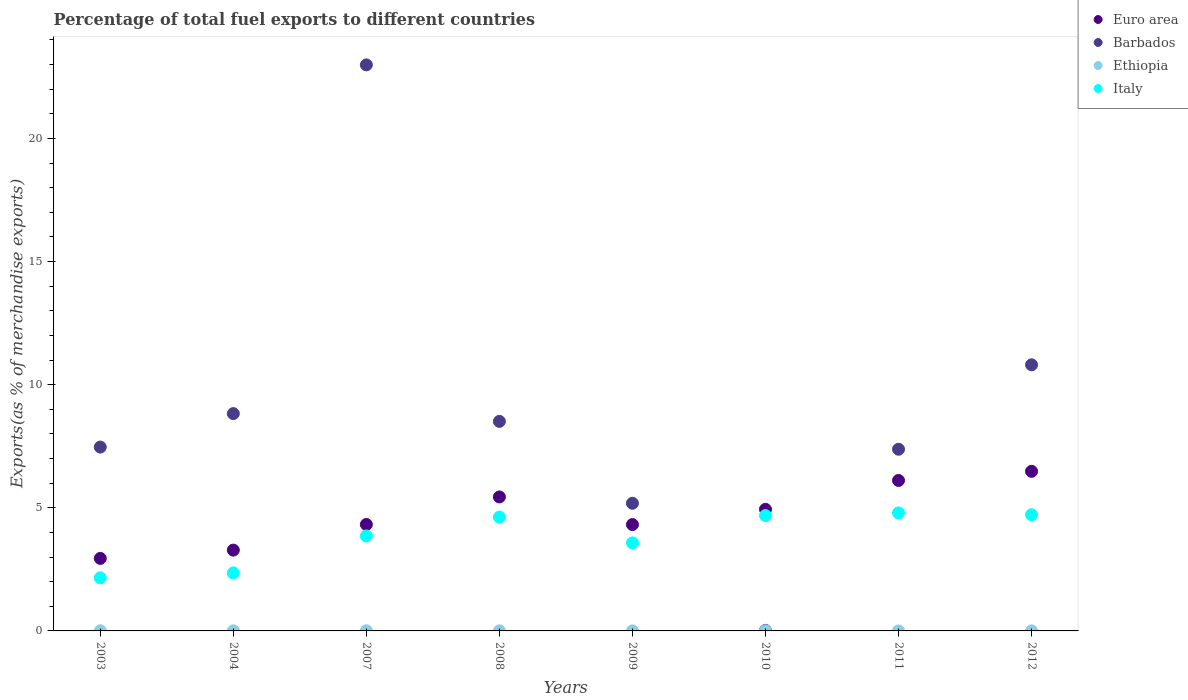What is the percentage of exports to different countries in Italy in 2010?
Your answer should be compact. 4.69. Across all years, what is the maximum percentage of exports to different countries in Ethiopia?
Give a very brief answer. 0.01. Across all years, what is the minimum percentage of exports to different countries in Barbados?
Offer a very short reply. 0.02. What is the total percentage of exports to different countries in Barbados in the graph?
Your answer should be compact. 71.18. What is the difference between the percentage of exports to different countries in Ethiopia in 2004 and that in 2008?
Provide a succinct answer. -0. What is the difference between the percentage of exports to different countries in Barbados in 2004 and the percentage of exports to different countries in Ethiopia in 2003?
Your response must be concise. 8.82. What is the average percentage of exports to different countries in Euro area per year?
Your response must be concise. 4.73. In the year 2007, what is the difference between the percentage of exports to different countries in Ethiopia and percentage of exports to different countries in Euro area?
Ensure brevity in your answer.  -4.32. What is the ratio of the percentage of exports to different countries in Euro area in 2003 to that in 2007?
Your answer should be very brief. 0.68. Is the difference between the percentage of exports to different countries in Ethiopia in 2004 and 2011 greater than the difference between the percentage of exports to different countries in Euro area in 2004 and 2011?
Offer a terse response. Yes. What is the difference between the highest and the second highest percentage of exports to different countries in Italy?
Provide a succinct answer. 0.07. What is the difference between the highest and the lowest percentage of exports to different countries in Ethiopia?
Provide a succinct answer. 0.01. Is it the case that in every year, the sum of the percentage of exports to different countries in Italy and percentage of exports to different countries in Barbados  is greater than the sum of percentage of exports to different countries in Euro area and percentage of exports to different countries in Ethiopia?
Provide a short and direct response. No. Is the percentage of exports to different countries in Ethiopia strictly greater than the percentage of exports to different countries in Euro area over the years?
Provide a short and direct response. No. Is the percentage of exports to different countries in Ethiopia strictly less than the percentage of exports to different countries in Italy over the years?
Keep it short and to the point. Yes. How many dotlines are there?
Ensure brevity in your answer.  4. What is the difference between two consecutive major ticks on the Y-axis?
Your response must be concise. 5. Are the values on the major ticks of Y-axis written in scientific E-notation?
Your answer should be very brief. No. Does the graph contain grids?
Keep it short and to the point. No. How are the legend labels stacked?
Offer a terse response. Vertical. What is the title of the graph?
Make the answer very short. Percentage of total fuel exports to different countries. Does "Macedonia" appear as one of the legend labels in the graph?
Your answer should be very brief. No. What is the label or title of the X-axis?
Your response must be concise. Years. What is the label or title of the Y-axis?
Give a very brief answer. Exports(as % of merchandise exports). What is the Exports(as % of merchandise exports) in Euro area in 2003?
Provide a short and direct response. 2.95. What is the Exports(as % of merchandise exports) in Barbados in 2003?
Your answer should be very brief. 7.47. What is the Exports(as % of merchandise exports) of Ethiopia in 2003?
Ensure brevity in your answer.  0.01. What is the Exports(as % of merchandise exports) of Italy in 2003?
Offer a very short reply. 2.16. What is the Exports(as % of merchandise exports) in Euro area in 2004?
Your response must be concise. 3.28. What is the Exports(as % of merchandise exports) of Barbados in 2004?
Give a very brief answer. 8.83. What is the Exports(as % of merchandise exports) of Ethiopia in 2004?
Your response must be concise. 0. What is the Exports(as % of merchandise exports) in Italy in 2004?
Ensure brevity in your answer.  2.36. What is the Exports(as % of merchandise exports) in Euro area in 2007?
Give a very brief answer. 4.32. What is the Exports(as % of merchandise exports) of Barbados in 2007?
Your response must be concise. 22.99. What is the Exports(as % of merchandise exports) of Ethiopia in 2007?
Make the answer very short. 0.01. What is the Exports(as % of merchandise exports) in Italy in 2007?
Offer a very short reply. 3.86. What is the Exports(as % of merchandise exports) in Euro area in 2008?
Ensure brevity in your answer.  5.44. What is the Exports(as % of merchandise exports) of Barbados in 2008?
Give a very brief answer. 8.51. What is the Exports(as % of merchandise exports) in Ethiopia in 2008?
Keep it short and to the point. 0.01. What is the Exports(as % of merchandise exports) of Italy in 2008?
Offer a very short reply. 4.63. What is the Exports(as % of merchandise exports) in Euro area in 2009?
Offer a terse response. 4.32. What is the Exports(as % of merchandise exports) of Barbados in 2009?
Give a very brief answer. 5.18. What is the Exports(as % of merchandise exports) in Ethiopia in 2009?
Ensure brevity in your answer.  0. What is the Exports(as % of merchandise exports) of Italy in 2009?
Ensure brevity in your answer.  3.58. What is the Exports(as % of merchandise exports) in Euro area in 2010?
Your answer should be very brief. 4.94. What is the Exports(as % of merchandise exports) of Barbados in 2010?
Offer a terse response. 0.02. What is the Exports(as % of merchandise exports) of Ethiopia in 2010?
Keep it short and to the point. 0. What is the Exports(as % of merchandise exports) in Italy in 2010?
Make the answer very short. 4.69. What is the Exports(as % of merchandise exports) of Euro area in 2011?
Your answer should be compact. 6.11. What is the Exports(as % of merchandise exports) of Barbados in 2011?
Offer a very short reply. 7.38. What is the Exports(as % of merchandise exports) in Ethiopia in 2011?
Offer a very short reply. 1.01193698658586e-5. What is the Exports(as % of merchandise exports) of Italy in 2011?
Ensure brevity in your answer.  4.79. What is the Exports(as % of merchandise exports) in Euro area in 2012?
Provide a short and direct response. 6.48. What is the Exports(as % of merchandise exports) of Barbados in 2012?
Give a very brief answer. 10.81. What is the Exports(as % of merchandise exports) of Ethiopia in 2012?
Provide a short and direct response. 0. What is the Exports(as % of merchandise exports) of Italy in 2012?
Provide a short and direct response. 4.72. Across all years, what is the maximum Exports(as % of merchandise exports) of Euro area?
Offer a very short reply. 6.48. Across all years, what is the maximum Exports(as % of merchandise exports) of Barbados?
Make the answer very short. 22.99. Across all years, what is the maximum Exports(as % of merchandise exports) in Ethiopia?
Give a very brief answer. 0.01. Across all years, what is the maximum Exports(as % of merchandise exports) in Italy?
Offer a terse response. 4.79. Across all years, what is the minimum Exports(as % of merchandise exports) of Euro area?
Give a very brief answer. 2.95. Across all years, what is the minimum Exports(as % of merchandise exports) in Barbados?
Offer a very short reply. 0.02. Across all years, what is the minimum Exports(as % of merchandise exports) of Ethiopia?
Offer a very short reply. 1.01193698658586e-5. Across all years, what is the minimum Exports(as % of merchandise exports) of Italy?
Your response must be concise. 2.16. What is the total Exports(as % of merchandise exports) in Euro area in the graph?
Make the answer very short. 37.84. What is the total Exports(as % of merchandise exports) of Barbados in the graph?
Ensure brevity in your answer.  71.18. What is the total Exports(as % of merchandise exports) of Ethiopia in the graph?
Ensure brevity in your answer.  0.03. What is the total Exports(as % of merchandise exports) of Italy in the graph?
Provide a short and direct response. 30.77. What is the difference between the Exports(as % of merchandise exports) of Euro area in 2003 and that in 2004?
Your answer should be very brief. -0.34. What is the difference between the Exports(as % of merchandise exports) in Barbados in 2003 and that in 2004?
Keep it short and to the point. -1.36. What is the difference between the Exports(as % of merchandise exports) in Ethiopia in 2003 and that in 2004?
Give a very brief answer. 0. What is the difference between the Exports(as % of merchandise exports) in Italy in 2003 and that in 2004?
Provide a short and direct response. -0.2. What is the difference between the Exports(as % of merchandise exports) in Euro area in 2003 and that in 2007?
Offer a terse response. -1.38. What is the difference between the Exports(as % of merchandise exports) of Barbados in 2003 and that in 2007?
Offer a terse response. -15.52. What is the difference between the Exports(as % of merchandise exports) in Ethiopia in 2003 and that in 2007?
Provide a succinct answer. 0. What is the difference between the Exports(as % of merchandise exports) of Italy in 2003 and that in 2007?
Provide a succinct answer. -1.7. What is the difference between the Exports(as % of merchandise exports) in Euro area in 2003 and that in 2008?
Provide a succinct answer. -2.5. What is the difference between the Exports(as % of merchandise exports) in Barbados in 2003 and that in 2008?
Provide a short and direct response. -1.04. What is the difference between the Exports(as % of merchandise exports) of Ethiopia in 2003 and that in 2008?
Make the answer very short. 0. What is the difference between the Exports(as % of merchandise exports) in Italy in 2003 and that in 2008?
Your response must be concise. -2.47. What is the difference between the Exports(as % of merchandise exports) in Euro area in 2003 and that in 2009?
Offer a very short reply. -1.37. What is the difference between the Exports(as % of merchandise exports) in Barbados in 2003 and that in 2009?
Offer a terse response. 2.28. What is the difference between the Exports(as % of merchandise exports) in Ethiopia in 2003 and that in 2009?
Provide a short and direct response. 0.01. What is the difference between the Exports(as % of merchandise exports) of Italy in 2003 and that in 2009?
Make the answer very short. -1.42. What is the difference between the Exports(as % of merchandise exports) in Euro area in 2003 and that in 2010?
Give a very brief answer. -1.99. What is the difference between the Exports(as % of merchandise exports) in Barbados in 2003 and that in 2010?
Give a very brief answer. 7.44. What is the difference between the Exports(as % of merchandise exports) of Ethiopia in 2003 and that in 2010?
Your response must be concise. 0. What is the difference between the Exports(as % of merchandise exports) in Italy in 2003 and that in 2010?
Your answer should be very brief. -2.53. What is the difference between the Exports(as % of merchandise exports) of Euro area in 2003 and that in 2011?
Keep it short and to the point. -3.17. What is the difference between the Exports(as % of merchandise exports) in Barbados in 2003 and that in 2011?
Give a very brief answer. 0.09. What is the difference between the Exports(as % of merchandise exports) of Ethiopia in 2003 and that in 2011?
Give a very brief answer. 0.01. What is the difference between the Exports(as % of merchandise exports) in Italy in 2003 and that in 2011?
Ensure brevity in your answer.  -2.63. What is the difference between the Exports(as % of merchandise exports) of Euro area in 2003 and that in 2012?
Your response must be concise. -3.54. What is the difference between the Exports(as % of merchandise exports) in Barbados in 2003 and that in 2012?
Make the answer very short. -3.34. What is the difference between the Exports(as % of merchandise exports) in Ethiopia in 2003 and that in 2012?
Offer a very short reply. 0.01. What is the difference between the Exports(as % of merchandise exports) in Italy in 2003 and that in 2012?
Provide a short and direct response. -2.56. What is the difference between the Exports(as % of merchandise exports) in Euro area in 2004 and that in 2007?
Keep it short and to the point. -1.04. What is the difference between the Exports(as % of merchandise exports) of Barbados in 2004 and that in 2007?
Offer a very short reply. -14.16. What is the difference between the Exports(as % of merchandise exports) in Ethiopia in 2004 and that in 2007?
Give a very brief answer. -0. What is the difference between the Exports(as % of merchandise exports) of Italy in 2004 and that in 2007?
Offer a terse response. -1.5. What is the difference between the Exports(as % of merchandise exports) of Euro area in 2004 and that in 2008?
Your answer should be very brief. -2.16. What is the difference between the Exports(as % of merchandise exports) of Barbados in 2004 and that in 2008?
Offer a very short reply. 0.32. What is the difference between the Exports(as % of merchandise exports) in Ethiopia in 2004 and that in 2008?
Your answer should be very brief. -0. What is the difference between the Exports(as % of merchandise exports) in Italy in 2004 and that in 2008?
Offer a terse response. -2.27. What is the difference between the Exports(as % of merchandise exports) in Euro area in 2004 and that in 2009?
Give a very brief answer. -1.04. What is the difference between the Exports(as % of merchandise exports) in Barbados in 2004 and that in 2009?
Offer a terse response. 3.64. What is the difference between the Exports(as % of merchandise exports) in Ethiopia in 2004 and that in 2009?
Offer a terse response. 0. What is the difference between the Exports(as % of merchandise exports) in Italy in 2004 and that in 2009?
Provide a succinct answer. -1.22. What is the difference between the Exports(as % of merchandise exports) of Euro area in 2004 and that in 2010?
Make the answer very short. -1.66. What is the difference between the Exports(as % of merchandise exports) in Barbados in 2004 and that in 2010?
Your answer should be very brief. 8.8. What is the difference between the Exports(as % of merchandise exports) of Ethiopia in 2004 and that in 2010?
Ensure brevity in your answer.  0. What is the difference between the Exports(as % of merchandise exports) in Italy in 2004 and that in 2010?
Provide a succinct answer. -2.33. What is the difference between the Exports(as % of merchandise exports) of Euro area in 2004 and that in 2011?
Offer a terse response. -2.83. What is the difference between the Exports(as % of merchandise exports) of Barbados in 2004 and that in 2011?
Your answer should be compact. 1.45. What is the difference between the Exports(as % of merchandise exports) in Ethiopia in 2004 and that in 2011?
Ensure brevity in your answer.  0. What is the difference between the Exports(as % of merchandise exports) of Italy in 2004 and that in 2011?
Your answer should be compact. -2.44. What is the difference between the Exports(as % of merchandise exports) in Euro area in 2004 and that in 2012?
Provide a short and direct response. -3.2. What is the difference between the Exports(as % of merchandise exports) of Barbados in 2004 and that in 2012?
Your answer should be very brief. -1.98. What is the difference between the Exports(as % of merchandise exports) of Ethiopia in 2004 and that in 2012?
Your answer should be compact. 0. What is the difference between the Exports(as % of merchandise exports) in Italy in 2004 and that in 2012?
Keep it short and to the point. -2.36. What is the difference between the Exports(as % of merchandise exports) in Euro area in 2007 and that in 2008?
Your answer should be very brief. -1.12. What is the difference between the Exports(as % of merchandise exports) in Barbados in 2007 and that in 2008?
Offer a terse response. 14.48. What is the difference between the Exports(as % of merchandise exports) in Italy in 2007 and that in 2008?
Make the answer very short. -0.77. What is the difference between the Exports(as % of merchandise exports) in Euro area in 2007 and that in 2009?
Your response must be concise. 0. What is the difference between the Exports(as % of merchandise exports) in Barbados in 2007 and that in 2009?
Your answer should be compact. 17.8. What is the difference between the Exports(as % of merchandise exports) of Ethiopia in 2007 and that in 2009?
Your response must be concise. 0.01. What is the difference between the Exports(as % of merchandise exports) of Italy in 2007 and that in 2009?
Ensure brevity in your answer.  0.28. What is the difference between the Exports(as % of merchandise exports) of Euro area in 2007 and that in 2010?
Offer a very short reply. -0.62. What is the difference between the Exports(as % of merchandise exports) of Barbados in 2007 and that in 2010?
Make the answer very short. 22.97. What is the difference between the Exports(as % of merchandise exports) of Ethiopia in 2007 and that in 2010?
Ensure brevity in your answer.  0. What is the difference between the Exports(as % of merchandise exports) of Italy in 2007 and that in 2010?
Your answer should be compact. -0.83. What is the difference between the Exports(as % of merchandise exports) of Euro area in 2007 and that in 2011?
Make the answer very short. -1.79. What is the difference between the Exports(as % of merchandise exports) of Barbados in 2007 and that in 2011?
Your answer should be very brief. 15.61. What is the difference between the Exports(as % of merchandise exports) of Ethiopia in 2007 and that in 2011?
Your response must be concise. 0.01. What is the difference between the Exports(as % of merchandise exports) in Italy in 2007 and that in 2011?
Your response must be concise. -0.93. What is the difference between the Exports(as % of merchandise exports) in Euro area in 2007 and that in 2012?
Provide a succinct answer. -2.16. What is the difference between the Exports(as % of merchandise exports) in Barbados in 2007 and that in 2012?
Your answer should be compact. 12.18. What is the difference between the Exports(as % of merchandise exports) of Ethiopia in 2007 and that in 2012?
Your response must be concise. 0. What is the difference between the Exports(as % of merchandise exports) in Italy in 2007 and that in 2012?
Your answer should be very brief. -0.86. What is the difference between the Exports(as % of merchandise exports) of Euro area in 2008 and that in 2009?
Your answer should be compact. 1.12. What is the difference between the Exports(as % of merchandise exports) in Barbados in 2008 and that in 2009?
Ensure brevity in your answer.  3.33. What is the difference between the Exports(as % of merchandise exports) of Ethiopia in 2008 and that in 2009?
Make the answer very short. 0. What is the difference between the Exports(as % of merchandise exports) of Italy in 2008 and that in 2009?
Ensure brevity in your answer.  1.05. What is the difference between the Exports(as % of merchandise exports) of Euro area in 2008 and that in 2010?
Offer a very short reply. 0.5. What is the difference between the Exports(as % of merchandise exports) in Barbados in 2008 and that in 2010?
Give a very brief answer. 8.49. What is the difference between the Exports(as % of merchandise exports) of Ethiopia in 2008 and that in 2010?
Offer a very short reply. 0. What is the difference between the Exports(as % of merchandise exports) in Italy in 2008 and that in 2010?
Give a very brief answer. -0.06. What is the difference between the Exports(as % of merchandise exports) of Euro area in 2008 and that in 2011?
Provide a short and direct response. -0.67. What is the difference between the Exports(as % of merchandise exports) in Barbados in 2008 and that in 2011?
Offer a terse response. 1.13. What is the difference between the Exports(as % of merchandise exports) in Ethiopia in 2008 and that in 2011?
Provide a succinct answer. 0.01. What is the difference between the Exports(as % of merchandise exports) of Italy in 2008 and that in 2011?
Provide a short and direct response. -0.17. What is the difference between the Exports(as % of merchandise exports) in Euro area in 2008 and that in 2012?
Offer a very short reply. -1.04. What is the difference between the Exports(as % of merchandise exports) in Barbados in 2008 and that in 2012?
Your answer should be very brief. -2.3. What is the difference between the Exports(as % of merchandise exports) of Ethiopia in 2008 and that in 2012?
Provide a succinct answer. 0. What is the difference between the Exports(as % of merchandise exports) in Italy in 2008 and that in 2012?
Give a very brief answer. -0.09. What is the difference between the Exports(as % of merchandise exports) of Euro area in 2009 and that in 2010?
Give a very brief answer. -0.62. What is the difference between the Exports(as % of merchandise exports) of Barbados in 2009 and that in 2010?
Provide a succinct answer. 5.16. What is the difference between the Exports(as % of merchandise exports) in Ethiopia in 2009 and that in 2010?
Offer a terse response. -0. What is the difference between the Exports(as % of merchandise exports) of Italy in 2009 and that in 2010?
Your answer should be compact. -1.11. What is the difference between the Exports(as % of merchandise exports) in Euro area in 2009 and that in 2011?
Provide a short and direct response. -1.79. What is the difference between the Exports(as % of merchandise exports) of Barbados in 2009 and that in 2011?
Give a very brief answer. -2.19. What is the difference between the Exports(as % of merchandise exports) of Ethiopia in 2009 and that in 2011?
Your response must be concise. 0. What is the difference between the Exports(as % of merchandise exports) in Italy in 2009 and that in 2011?
Give a very brief answer. -1.22. What is the difference between the Exports(as % of merchandise exports) in Euro area in 2009 and that in 2012?
Your answer should be very brief. -2.16. What is the difference between the Exports(as % of merchandise exports) in Barbados in 2009 and that in 2012?
Give a very brief answer. -5.62. What is the difference between the Exports(as % of merchandise exports) in Ethiopia in 2009 and that in 2012?
Give a very brief answer. -0. What is the difference between the Exports(as % of merchandise exports) in Italy in 2009 and that in 2012?
Provide a succinct answer. -1.14. What is the difference between the Exports(as % of merchandise exports) in Euro area in 2010 and that in 2011?
Give a very brief answer. -1.17. What is the difference between the Exports(as % of merchandise exports) of Barbados in 2010 and that in 2011?
Make the answer very short. -7.36. What is the difference between the Exports(as % of merchandise exports) in Ethiopia in 2010 and that in 2011?
Your response must be concise. 0. What is the difference between the Exports(as % of merchandise exports) in Italy in 2010 and that in 2011?
Give a very brief answer. -0.11. What is the difference between the Exports(as % of merchandise exports) in Euro area in 2010 and that in 2012?
Your answer should be very brief. -1.54. What is the difference between the Exports(as % of merchandise exports) in Barbados in 2010 and that in 2012?
Make the answer very short. -10.79. What is the difference between the Exports(as % of merchandise exports) of Ethiopia in 2010 and that in 2012?
Give a very brief answer. 0. What is the difference between the Exports(as % of merchandise exports) of Italy in 2010 and that in 2012?
Offer a terse response. -0.03. What is the difference between the Exports(as % of merchandise exports) in Euro area in 2011 and that in 2012?
Make the answer very short. -0.37. What is the difference between the Exports(as % of merchandise exports) in Barbados in 2011 and that in 2012?
Offer a very short reply. -3.43. What is the difference between the Exports(as % of merchandise exports) in Ethiopia in 2011 and that in 2012?
Your answer should be compact. -0. What is the difference between the Exports(as % of merchandise exports) of Italy in 2011 and that in 2012?
Ensure brevity in your answer.  0.07. What is the difference between the Exports(as % of merchandise exports) of Euro area in 2003 and the Exports(as % of merchandise exports) of Barbados in 2004?
Ensure brevity in your answer.  -5.88. What is the difference between the Exports(as % of merchandise exports) in Euro area in 2003 and the Exports(as % of merchandise exports) in Ethiopia in 2004?
Give a very brief answer. 2.94. What is the difference between the Exports(as % of merchandise exports) in Euro area in 2003 and the Exports(as % of merchandise exports) in Italy in 2004?
Ensure brevity in your answer.  0.59. What is the difference between the Exports(as % of merchandise exports) of Barbados in 2003 and the Exports(as % of merchandise exports) of Ethiopia in 2004?
Ensure brevity in your answer.  7.46. What is the difference between the Exports(as % of merchandise exports) in Barbados in 2003 and the Exports(as % of merchandise exports) in Italy in 2004?
Provide a short and direct response. 5.11. What is the difference between the Exports(as % of merchandise exports) in Ethiopia in 2003 and the Exports(as % of merchandise exports) in Italy in 2004?
Provide a succinct answer. -2.35. What is the difference between the Exports(as % of merchandise exports) of Euro area in 2003 and the Exports(as % of merchandise exports) of Barbados in 2007?
Offer a very short reply. -20.04. What is the difference between the Exports(as % of merchandise exports) in Euro area in 2003 and the Exports(as % of merchandise exports) in Ethiopia in 2007?
Ensure brevity in your answer.  2.94. What is the difference between the Exports(as % of merchandise exports) in Euro area in 2003 and the Exports(as % of merchandise exports) in Italy in 2007?
Provide a short and direct response. -0.91. What is the difference between the Exports(as % of merchandise exports) of Barbados in 2003 and the Exports(as % of merchandise exports) of Ethiopia in 2007?
Your answer should be very brief. 7.46. What is the difference between the Exports(as % of merchandise exports) of Barbados in 2003 and the Exports(as % of merchandise exports) of Italy in 2007?
Provide a succinct answer. 3.61. What is the difference between the Exports(as % of merchandise exports) of Ethiopia in 2003 and the Exports(as % of merchandise exports) of Italy in 2007?
Your answer should be very brief. -3.85. What is the difference between the Exports(as % of merchandise exports) of Euro area in 2003 and the Exports(as % of merchandise exports) of Barbados in 2008?
Ensure brevity in your answer.  -5.56. What is the difference between the Exports(as % of merchandise exports) in Euro area in 2003 and the Exports(as % of merchandise exports) in Ethiopia in 2008?
Provide a short and direct response. 2.94. What is the difference between the Exports(as % of merchandise exports) in Euro area in 2003 and the Exports(as % of merchandise exports) in Italy in 2008?
Your answer should be very brief. -1.68. What is the difference between the Exports(as % of merchandise exports) in Barbados in 2003 and the Exports(as % of merchandise exports) in Ethiopia in 2008?
Your answer should be compact. 7.46. What is the difference between the Exports(as % of merchandise exports) in Barbados in 2003 and the Exports(as % of merchandise exports) in Italy in 2008?
Your answer should be very brief. 2.84. What is the difference between the Exports(as % of merchandise exports) of Ethiopia in 2003 and the Exports(as % of merchandise exports) of Italy in 2008?
Give a very brief answer. -4.62. What is the difference between the Exports(as % of merchandise exports) in Euro area in 2003 and the Exports(as % of merchandise exports) in Barbados in 2009?
Your answer should be compact. -2.24. What is the difference between the Exports(as % of merchandise exports) in Euro area in 2003 and the Exports(as % of merchandise exports) in Ethiopia in 2009?
Keep it short and to the point. 2.94. What is the difference between the Exports(as % of merchandise exports) in Euro area in 2003 and the Exports(as % of merchandise exports) in Italy in 2009?
Provide a succinct answer. -0.63. What is the difference between the Exports(as % of merchandise exports) of Barbados in 2003 and the Exports(as % of merchandise exports) of Ethiopia in 2009?
Your response must be concise. 7.47. What is the difference between the Exports(as % of merchandise exports) in Barbados in 2003 and the Exports(as % of merchandise exports) in Italy in 2009?
Your answer should be compact. 3.89. What is the difference between the Exports(as % of merchandise exports) in Ethiopia in 2003 and the Exports(as % of merchandise exports) in Italy in 2009?
Give a very brief answer. -3.57. What is the difference between the Exports(as % of merchandise exports) in Euro area in 2003 and the Exports(as % of merchandise exports) in Barbados in 2010?
Offer a very short reply. 2.92. What is the difference between the Exports(as % of merchandise exports) of Euro area in 2003 and the Exports(as % of merchandise exports) of Ethiopia in 2010?
Ensure brevity in your answer.  2.94. What is the difference between the Exports(as % of merchandise exports) in Euro area in 2003 and the Exports(as % of merchandise exports) in Italy in 2010?
Provide a succinct answer. -1.74. What is the difference between the Exports(as % of merchandise exports) of Barbados in 2003 and the Exports(as % of merchandise exports) of Ethiopia in 2010?
Provide a succinct answer. 7.46. What is the difference between the Exports(as % of merchandise exports) of Barbados in 2003 and the Exports(as % of merchandise exports) of Italy in 2010?
Offer a terse response. 2.78. What is the difference between the Exports(as % of merchandise exports) of Ethiopia in 2003 and the Exports(as % of merchandise exports) of Italy in 2010?
Offer a very short reply. -4.68. What is the difference between the Exports(as % of merchandise exports) in Euro area in 2003 and the Exports(as % of merchandise exports) in Barbados in 2011?
Offer a terse response. -4.43. What is the difference between the Exports(as % of merchandise exports) of Euro area in 2003 and the Exports(as % of merchandise exports) of Ethiopia in 2011?
Provide a short and direct response. 2.95. What is the difference between the Exports(as % of merchandise exports) of Euro area in 2003 and the Exports(as % of merchandise exports) of Italy in 2011?
Make the answer very short. -1.85. What is the difference between the Exports(as % of merchandise exports) of Barbados in 2003 and the Exports(as % of merchandise exports) of Ethiopia in 2011?
Offer a very short reply. 7.47. What is the difference between the Exports(as % of merchandise exports) of Barbados in 2003 and the Exports(as % of merchandise exports) of Italy in 2011?
Offer a terse response. 2.67. What is the difference between the Exports(as % of merchandise exports) in Ethiopia in 2003 and the Exports(as % of merchandise exports) in Italy in 2011?
Ensure brevity in your answer.  -4.78. What is the difference between the Exports(as % of merchandise exports) in Euro area in 2003 and the Exports(as % of merchandise exports) in Barbados in 2012?
Provide a short and direct response. -7.86. What is the difference between the Exports(as % of merchandise exports) of Euro area in 2003 and the Exports(as % of merchandise exports) of Ethiopia in 2012?
Your answer should be very brief. 2.94. What is the difference between the Exports(as % of merchandise exports) of Euro area in 2003 and the Exports(as % of merchandise exports) of Italy in 2012?
Offer a terse response. -1.77. What is the difference between the Exports(as % of merchandise exports) of Barbados in 2003 and the Exports(as % of merchandise exports) of Ethiopia in 2012?
Give a very brief answer. 7.46. What is the difference between the Exports(as % of merchandise exports) in Barbados in 2003 and the Exports(as % of merchandise exports) in Italy in 2012?
Ensure brevity in your answer.  2.75. What is the difference between the Exports(as % of merchandise exports) of Ethiopia in 2003 and the Exports(as % of merchandise exports) of Italy in 2012?
Provide a succinct answer. -4.71. What is the difference between the Exports(as % of merchandise exports) in Euro area in 2004 and the Exports(as % of merchandise exports) in Barbados in 2007?
Your answer should be compact. -19.71. What is the difference between the Exports(as % of merchandise exports) of Euro area in 2004 and the Exports(as % of merchandise exports) of Ethiopia in 2007?
Offer a very short reply. 3.28. What is the difference between the Exports(as % of merchandise exports) of Euro area in 2004 and the Exports(as % of merchandise exports) of Italy in 2007?
Offer a very short reply. -0.58. What is the difference between the Exports(as % of merchandise exports) of Barbados in 2004 and the Exports(as % of merchandise exports) of Ethiopia in 2007?
Provide a short and direct response. 8.82. What is the difference between the Exports(as % of merchandise exports) in Barbados in 2004 and the Exports(as % of merchandise exports) in Italy in 2007?
Ensure brevity in your answer.  4.97. What is the difference between the Exports(as % of merchandise exports) of Ethiopia in 2004 and the Exports(as % of merchandise exports) of Italy in 2007?
Your answer should be very brief. -3.85. What is the difference between the Exports(as % of merchandise exports) in Euro area in 2004 and the Exports(as % of merchandise exports) in Barbados in 2008?
Give a very brief answer. -5.23. What is the difference between the Exports(as % of merchandise exports) in Euro area in 2004 and the Exports(as % of merchandise exports) in Ethiopia in 2008?
Keep it short and to the point. 3.28. What is the difference between the Exports(as % of merchandise exports) in Euro area in 2004 and the Exports(as % of merchandise exports) in Italy in 2008?
Provide a succinct answer. -1.34. What is the difference between the Exports(as % of merchandise exports) of Barbados in 2004 and the Exports(as % of merchandise exports) of Ethiopia in 2008?
Your response must be concise. 8.82. What is the difference between the Exports(as % of merchandise exports) of Barbados in 2004 and the Exports(as % of merchandise exports) of Italy in 2008?
Provide a short and direct response. 4.2. What is the difference between the Exports(as % of merchandise exports) in Ethiopia in 2004 and the Exports(as % of merchandise exports) in Italy in 2008?
Provide a succinct answer. -4.62. What is the difference between the Exports(as % of merchandise exports) in Euro area in 2004 and the Exports(as % of merchandise exports) in Barbados in 2009?
Provide a succinct answer. -1.9. What is the difference between the Exports(as % of merchandise exports) of Euro area in 2004 and the Exports(as % of merchandise exports) of Ethiopia in 2009?
Your response must be concise. 3.28. What is the difference between the Exports(as % of merchandise exports) in Euro area in 2004 and the Exports(as % of merchandise exports) in Italy in 2009?
Make the answer very short. -0.29. What is the difference between the Exports(as % of merchandise exports) of Barbados in 2004 and the Exports(as % of merchandise exports) of Ethiopia in 2009?
Ensure brevity in your answer.  8.82. What is the difference between the Exports(as % of merchandise exports) of Barbados in 2004 and the Exports(as % of merchandise exports) of Italy in 2009?
Your answer should be compact. 5.25. What is the difference between the Exports(as % of merchandise exports) of Ethiopia in 2004 and the Exports(as % of merchandise exports) of Italy in 2009?
Ensure brevity in your answer.  -3.57. What is the difference between the Exports(as % of merchandise exports) of Euro area in 2004 and the Exports(as % of merchandise exports) of Barbados in 2010?
Provide a succinct answer. 3.26. What is the difference between the Exports(as % of merchandise exports) in Euro area in 2004 and the Exports(as % of merchandise exports) in Ethiopia in 2010?
Your response must be concise. 3.28. What is the difference between the Exports(as % of merchandise exports) of Euro area in 2004 and the Exports(as % of merchandise exports) of Italy in 2010?
Your answer should be very brief. -1.4. What is the difference between the Exports(as % of merchandise exports) in Barbados in 2004 and the Exports(as % of merchandise exports) in Ethiopia in 2010?
Your response must be concise. 8.82. What is the difference between the Exports(as % of merchandise exports) in Barbados in 2004 and the Exports(as % of merchandise exports) in Italy in 2010?
Your answer should be compact. 4.14. What is the difference between the Exports(as % of merchandise exports) of Ethiopia in 2004 and the Exports(as % of merchandise exports) of Italy in 2010?
Your answer should be compact. -4.68. What is the difference between the Exports(as % of merchandise exports) of Euro area in 2004 and the Exports(as % of merchandise exports) of Barbados in 2011?
Offer a terse response. -4.1. What is the difference between the Exports(as % of merchandise exports) of Euro area in 2004 and the Exports(as % of merchandise exports) of Ethiopia in 2011?
Provide a succinct answer. 3.28. What is the difference between the Exports(as % of merchandise exports) in Euro area in 2004 and the Exports(as % of merchandise exports) in Italy in 2011?
Provide a succinct answer. -1.51. What is the difference between the Exports(as % of merchandise exports) in Barbados in 2004 and the Exports(as % of merchandise exports) in Ethiopia in 2011?
Your answer should be very brief. 8.83. What is the difference between the Exports(as % of merchandise exports) of Barbados in 2004 and the Exports(as % of merchandise exports) of Italy in 2011?
Provide a succinct answer. 4.03. What is the difference between the Exports(as % of merchandise exports) in Ethiopia in 2004 and the Exports(as % of merchandise exports) in Italy in 2011?
Your response must be concise. -4.79. What is the difference between the Exports(as % of merchandise exports) of Euro area in 2004 and the Exports(as % of merchandise exports) of Barbados in 2012?
Your answer should be compact. -7.53. What is the difference between the Exports(as % of merchandise exports) in Euro area in 2004 and the Exports(as % of merchandise exports) in Ethiopia in 2012?
Provide a succinct answer. 3.28. What is the difference between the Exports(as % of merchandise exports) in Euro area in 2004 and the Exports(as % of merchandise exports) in Italy in 2012?
Offer a terse response. -1.44. What is the difference between the Exports(as % of merchandise exports) of Barbados in 2004 and the Exports(as % of merchandise exports) of Ethiopia in 2012?
Make the answer very short. 8.82. What is the difference between the Exports(as % of merchandise exports) of Barbados in 2004 and the Exports(as % of merchandise exports) of Italy in 2012?
Provide a short and direct response. 4.11. What is the difference between the Exports(as % of merchandise exports) in Ethiopia in 2004 and the Exports(as % of merchandise exports) in Italy in 2012?
Provide a succinct answer. -4.71. What is the difference between the Exports(as % of merchandise exports) in Euro area in 2007 and the Exports(as % of merchandise exports) in Barbados in 2008?
Offer a very short reply. -4.19. What is the difference between the Exports(as % of merchandise exports) of Euro area in 2007 and the Exports(as % of merchandise exports) of Ethiopia in 2008?
Your answer should be very brief. 4.32. What is the difference between the Exports(as % of merchandise exports) in Euro area in 2007 and the Exports(as % of merchandise exports) in Italy in 2008?
Your response must be concise. -0.3. What is the difference between the Exports(as % of merchandise exports) of Barbados in 2007 and the Exports(as % of merchandise exports) of Ethiopia in 2008?
Your answer should be compact. 22.98. What is the difference between the Exports(as % of merchandise exports) in Barbados in 2007 and the Exports(as % of merchandise exports) in Italy in 2008?
Provide a short and direct response. 18.36. What is the difference between the Exports(as % of merchandise exports) of Ethiopia in 2007 and the Exports(as % of merchandise exports) of Italy in 2008?
Provide a succinct answer. -4.62. What is the difference between the Exports(as % of merchandise exports) in Euro area in 2007 and the Exports(as % of merchandise exports) in Barbados in 2009?
Your answer should be compact. -0.86. What is the difference between the Exports(as % of merchandise exports) in Euro area in 2007 and the Exports(as % of merchandise exports) in Ethiopia in 2009?
Your answer should be compact. 4.32. What is the difference between the Exports(as % of merchandise exports) in Euro area in 2007 and the Exports(as % of merchandise exports) in Italy in 2009?
Your response must be concise. 0.75. What is the difference between the Exports(as % of merchandise exports) of Barbados in 2007 and the Exports(as % of merchandise exports) of Ethiopia in 2009?
Your response must be concise. 22.99. What is the difference between the Exports(as % of merchandise exports) in Barbados in 2007 and the Exports(as % of merchandise exports) in Italy in 2009?
Keep it short and to the point. 19.41. What is the difference between the Exports(as % of merchandise exports) of Ethiopia in 2007 and the Exports(as % of merchandise exports) of Italy in 2009?
Provide a succinct answer. -3.57. What is the difference between the Exports(as % of merchandise exports) of Euro area in 2007 and the Exports(as % of merchandise exports) of Barbados in 2010?
Offer a terse response. 4.3. What is the difference between the Exports(as % of merchandise exports) of Euro area in 2007 and the Exports(as % of merchandise exports) of Ethiopia in 2010?
Provide a short and direct response. 4.32. What is the difference between the Exports(as % of merchandise exports) of Euro area in 2007 and the Exports(as % of merchandise exports) of Italy in 2010?
Offer a terse response. -0.36. What is the difference between the Exports(as % of merchandise exports) in Barbados in 2007 and the Exports(as % of merchandise exports) in Ethiopia in 2010?
Offer a very short reply. 22.98. What is the difference between the Exports(as % of merchandise exports) of Barbados in 2007 and the Exports(as % of merchandise exports) of Italy in 2010?
Make the answer very short. 18.3. What is the difference between the Exports(as % of merchandise exports) of Ethiopia in 2007 and the Exports(as % of merchandise exports) of Italy in 2010?
Your answer should be very brief. -4.68. What is the difference between the Exports(as % of merchandise exports) of Euro area in 2007 and the Exports(as % of merchandise exports) of Barbados in 2011?
Provide a short and direct response. -3.06. What is the difference between the Exports(as % of merchandise exports) of Euro area in 2007 and the Exports(as % of merchandise exports) of Ethiopia in 2011?
Ensure brevity in your answer.  4.32. What is the difference between the Exports(as % of merchandise exports) in Euro area in 2007 and the Exports(as % of merchandise exports) in Italy in 2011?
Your answer should be compact. -0.47. What is the difference between the Exports(as % of merchandise exports) of Barbados in 2007 and the Exports(as % of merchandise exports) of Ethiopia in 2011?
Provide a short and direct response. 22.99. What is the difference between the Exports(as % of merchandise exports) in Barbados in 2007 and the Exports(as % of merchandise exports) in Italy in 2011?
Your answer should be very brief. 18.2. What is the difference between the Exports(as % of merchandise exports) in Ethiopia in 2007 and the Exports(as % of merchandise exports) in Italy in 2011?
Make the answer very short. -4.79. What is the difference between the Exports(as % of merchandise exports) in Euro area in 2007 and the Exports(as % of merchandise exports) in Barbados in 2012?
Provide a succinct answer. -6.48. What is the difference between the Exports(as % of merchandise exports) of Euro area in 2007 and the Exports(as % of merchandise exports) of Ethiopia in 2012?
Provide a succinct answer. 4.32. What is the difference between the Exports(as % of merchandise exports) in Euro area in 2007 and the Exports(as % of merchandise exports) in Italy in 2012?
Your answer should be compact. -0.4. What is the difference between the Exports(as % of merchandise exports) in Barbados in 2007 and the Exports(as % of merchandise exports) in Ethiopia in 2012?
Make the answer very short. 22.99. What is the difference between the Exports(as % of merchandise exports) in Barbados in 2007 and the Exports(as % of merchandise exports) in Italy in 2012?
Offer a very short reply. 18.27. What is the difference between the Exports(as % of merchandise exports) of Ethiopia in 2007 and the Exports(as % of merchandise exports) of Italy in 2012?
Keep it short and to the point. -4.71. What is the difference between the Exports(as % of merchandise exports) of Euro area in 2008 and the Exports(as % of merchandise exports) of Barbados in 2009?
Give a very brief answer. 0.26. What is the difference between the Exports(as % of merchandise exports) in Euro area in 2008 and the Exports(as % of merchandise exports) in Ethiopia in 2009?
Give a very brief answer. 5.44. What is the difference between the Exports(as % of merchandise exports) of Euro area in 2008 and the Exports(as % of merchandise exports) of Italy in 2009?
Ensure brevity in your answer.  1.87. What is the difference between the Exports(as % of merchandise exports) of Barbados in 2008 and the Exports(as % of merchandise exports) of Ethiopia in 2009?
Your answer should be very brief. 8.51. What is the difference between the Exports(as % of merchandise exports) of Barbados in 2008 and the Exports(as % of merchandise exports) of Italy in 2009?
Ensure brevity in your answer.  4.93. What is the difference between the Exports(as % of merchandise exports) of Ethiopia in 2008 and the Exports(as % of merchandise exports) of Italy in 2009?
Offer a very short reply. -3.57. What is the difference between the Exports(as % of merchandise exports) of Euro area in 2008 and the Exports(as % of merchandise exports) of Barbados in 2010?
Your response must be concise. 5.42. What is the difference between the Exports(as % of merchandise exports) of Euro area in 2008 and the Exports(as % of merchandise exports) of Ethiopia in 2010?
Keep it short and to the point. 5.44. What is the difference between the Exports(as % of merchandise exports) in Euro area in 2008 and the Exports(as % of merchandise exports) in Italy in 2010?
Your answer should be very brief. 0.76. What is the difference between the Exports(as % of merchandise exports) in Barbados in 2008 and the Exports(as % of merchandise exports) in Ethiopia in 2010?
Ensure brevity in your answer.  8.51. What is the difference between the Exports(as % of merchandise exports) in Barbados in 2008 and the Exports(as % of merchandise exports) in Italy in 2010?
Make the answer very short. 3.82. What is the difference between the Exports(as % of merchandise exports) in Ethiopia in 2008 and the Exports(as % of merchandise exports) in Italy in 2010?
Keep it short and to the point. -4.68. What is the difference between the Exports(as % of merchandise exports) of Euro area in 2008 and the Exports(as % of merchandise exports) of Barbados in 2011?
Make the answer very short. -1.94. What is the difference between the Exports(as % of merchandise exports) in Euro area in 2008 and the Exports(as % of merchandise exports) in Ethiopia in 2011?
Offer a terse response. 5.44. What is the difference between the Exports(as % of merchandise exports) in Euro area in 2008 and the Exports(as % of merchandise exports) in Italy in 2011?
Your response must be concise. 0.65. What is the difference between the Exports(as % of merchandise exports) in Barbados in 2008 and the Exports(as % of merchandise exports) in Ethiopia in 2011?
Keep it short and to the point. 8.51. What is the difference between the Exports(as % of merchandise exports) in Barbados in 2008 and the Exports(as % of merchandise exports) in Italy in 2011?
Ensure brevity in your answer.  3.72. What is the difference between the Exports(as % of merchandise exports) in Ethiopia in 2008 and the Exports(as % of merchandise exports) in Italy in 2011?
Provide a short and direct response. -4.79. What is the difference between the Exports(as % of merchandise exports) of Euro area in 2008 and the Exports(as % of merchandise exports) of Barbados in 2012?
Your answer should be very brief. -5.37. What is the difference between the Exports(as % of merchandise exports) in Euro area in 2008 and the Exports(as % of merchandise exports) in Ethiopia in 2012?
Provide a succinct answer. 5.44. What is the difference between the Exports(as % of merchandise exports) of Euro area in 2008 and the Exports(as % of merchandise exports) of Italy in 2012?
Ensure brevity in your answer.  0.72. What is the difference between the Exports(as % of merchandise exports) of Barbados in 2008 and the Exports(as % of merchandise exports) of Ethiopia in 2012?
Provide a succinct answer. 8.51. What is the difference between the Exports(as % of merchandise exports) of Barbados in 2008 and the Exports(as % of merchandise exports) of Italy in 2012?
Provide a short and direct response. 3.79. What is the difference between the Exports(as % of merchandise exports) in Ethiopia in 2008 and the Exports(as % of merchandise exports) in Italy in 2012?
Your response must be concise. -4.71. What is the difference between the Exports(as % of merchandise exports) of Euro area in 2009 and the Exports(as % of merchandise exports) of Barbados in 2010?
Offer a terse response. 4.3. What is the difference between the Exports(as % of merchandise exports) of Euro area in 2009 and the Exports(as % of merchandise exports) of Ethiopia in 2010?
Offer a terse response. 4.32. What is the difference between the Exports(as % of merchandise exports) of Euro area in 2009 and the Exports(as % of merchandise exports) of Italy in 2010?
Provide a succinct answer. -0.37. What is the difference between the Exports(as % of merchandise exports) in Barbados in 2009 and the Exports(as % of merchandise exports) in Ethiopia in 2010?
Provide a succinct answer. 5.18. What is the difference between the Exports(as % of merchandise exports) in Barbados in 2009 and the Exports(as % of merchandise exports) in Italy in 2010?
Provide a short and direct response. 0.5. What is the difference between the Exports(as % of merchandise exports) of Ethiopia in 2009 and the Exports(as % of merchandise exports) of Italy in 2010?
Your answer should be very brief. -4.69. What is the difference between the Exports(as % of merchandise exports) of Euro area in 2009 and the Exports(as % of merchandise exports) of Barbados in 2011?
Your response must be concise. -3.06. What is the difference between the Exports(as % of merchandise exports) in Euro area in 2009 and the Exports(as % of merchandise exports) in Ethiopia in 2011?
Offer a terse response. 4.32. What is the difference between the Exports(as % of merchandise exports) in Euro area in 2009 and the Exports(as % of merchandise exports) in Italy in 2011?
Ensure brevity in your answer.  -0.47. What is the difference between the Exports(as % of merchandise exports) in Barbados in 2009 and the Exports(as % of merchandise exports) in Ethiopia in 2011?
Make the answer very short. 5.18. What is the difference between the Exports(as % of merchandise exports) in Barbados in 2009 and the Exports(as % of merchandise exports) in Italy in 2011?
Offer a very short reply. 0.39. What is the difference between the Exports(as % of merchandise exports) in Ethiopia in 2009 and the Exports(as % of merchandise exports) in Italy in 2011?
Give a very brief answer. -4.79. What is the difference between the Exports(as % of merchandise exports) in Euro area in 2009 and the Exports(as % of merchandise exports) in Barbados in 2012?
Make the answer very short. -6.49. What is the difference between the Exports(as % of merchandise exports) in Euro area in 2009 and the Exports(as % of merchandise exports) in Ethiopia in 2012?
Your answer should be very brief. 4.32. What is the difference between the Exports(as % of merchandise exports) in Euro area in 2009 and the Exports(as % of merchandise exports) in Italy in 2012?
Offer a very short reply. -0.4. What is the difference between the Exports(as % of merchandise exports) of Barbados in 2009 and the Exports(as % of merchandise exports) of Ethiopia in 2012?
Offer a very short reply. 5.18. What is the difference between the Exports(as % of merchandise exports) of Barbados in 2009 and the Exports(as % of merchandise exports) of Italy in 2012?
Ensure brevity in your answer.  0.47. What is the difference between the Exports(as % of merchandise exports) in Ethiopia in 2009 and the Exports(as % of merchandise exports) in Italy in 2012?
Give a very brief answer. -4.72. What is the difference between the Exports(as % of merchandise exports) in Euro area in 2010 and the Exports(as % of merchandise exports) in Barbados in 2011?
Offer a very short reply. -2.44. What is the difference between the Exports(as % of merchandise exports) in Euro area in 2010 and the Exports(as % of merchandise exports) in Ethiopia in 2011?
Keep it short and to the point. 4.94. What is the difference between the Exports(as % of merchandise exports) in Euro area in 2010 and the Exports(as % of merchandise exports) in Italy in 2011?
Your answer should be very brief. 0.15. What is the difference between the Exports(as % of merchandise exports) in Barbados in 2010 and the Exports(as % of merchandise exports) in Ethiopia in 2011?
Make the answer very short. 0.02. What is the difference between the Exports(as % of merchandise exports) in Barbados in 2010 and the Exports(as % of merchandise exports) in Italy in 2011?
Provide a succinct answer. -4.77. What is the difference between the Exports(as % of merchandise exports) of Ethiopia in 2010 and the Exports(as % of merchandise exports) of Italy in 2011?
Provide a succinct answer. -4.79. What is the difference between the Exports(as % of merchandise exports) of Euro area in 2010 and the Exports(as % of merchandise exports) of Barbados in 2012?
Your answer should be compact. -5.87. What is the difference between the Exports(as % of merchandise exports) of Euro area in 2010 and the Exports(as % of merchandise exports) of Ethiopia in 2012?
Your answer should be compact. 4.94. What is the difference between the Exports(as % of merchandise exports) of Euro area in 2010 and the Exports(as % of merchandise exports) of Italy in 2012?
Your answer should be very brief. 0.22. What is the difference between the Exports(as % of merchandise exports) of Barbados in 2010 and the Exports(as % of merchandise exports) of Ethiopia in 2012?
Give a very brief answer. 0.02. What is the difference between the Exports(as % of merchandise exports) in Barbados in 2010 and the Exports(as % of merchandise exports) in Italy in 2012?
Make the answer very short. -4.7. What is the difference between the Exports(as % of merchandise exports) of Ethiopia in 2010 and the Exports(as % of merchandise exports) of Italy in 2012?
Make the answer very short. -4.71. What is the difference between the Exports(as % of merchandise exports) in Euro area in 2011 and the Exports(as % of merchandise exports) in Barbados in 2012?
Offer a terse response. -4.7. What is the difference between the Exports(as % of merchandise exports) of Euro area in 2011 and the Exports(as % of merchandise exports) of Ethiopia in 2012?
Your answer should be compact. 6.11. What is the difference between the Exports(as % of merchandise exports) in Euro area in 2011 and the Exports(as % of merchandise exports) in Italy in 2012?
Make the answer very short. 1.39. What is the difference between the Exports(as % of merchandise exports) in Barbados in 2011 and the Exports(as % of merchandise exports) in Ethiopia in 2012?
Make the answer very short. 7.38. What is the difference between the Exports(as % of merchandise exports) of Barbados in 2011 and the Exports(as % of merchandise exports) of Italy in 2012?
Your response must be concise. 2.66. What is the difference between the Exports(as % of merchandise exports) of Ethiopia in 2011 and the Exports(as % of merchandise exports) of Italy in 2012?
Provide a short and direct response. -4.72. What is the average Exports(as % of merchandise exports) of Euro area per year?
Make the answer very short. 4.73. What is the average Exports(as % of merchandise exports) in Barbados per year?
Make the answer very short. 8.9. What is the average Exports(as % of merchandise exports) of Ethiopia per year?
Provide a short and direct response. 0. What is the average Exports(as % of merchandise exports) in Italy per year?
Your response must be concise. 3.85. In the year 2003, what is the difference between the Exports(as % of merchandise exports) of Euro area and Exports(as % of merchandise exports) of Barbados?
Offer a very short reply. -4.52. In the year 2003, what is the difference between the Exports(as % of merchandise exports) of Euro area and Exports(as % of merchandise exports) of Ethiopia?
Make the answer very short. 2.94. In the year 2003, what is the difference between the Exports(as % of merchandise exports) in Euro area and Exports(as % of merchandise exports) in Italy?
Make the answer very short. 0.79. In the year 2003, what is the difference between the Exports(as % of merchandise exports) of Barbados and Exports(as % of merchandise exports) of Ethiopia?
Your response must be concise. 7.46. In the year 2003, what is the difference between the Exports(as % of merchandise exports) in Barbados and Exports(as % of merchandise exports) in Italy?
Your answer should be compact. 5.31. In the year 2003, what is the difference between the Exports(as % of merchandise exports) of Ethiopia and Exports(as % of merchandise exports) of Italy?
Ensure brevity in your answer.  -2.15. In the year 2004, what is the difference between the Exports(as % of merchandise exports) of Euro area and Exports(as % of merchandise exports) of Barbados?
Ensure brevity in your answer.  -5.54. In the year 2004, what is the difference between the Exports(as % of merchandise exports) of Euro area and Exports(as % of merchandise exports) of Ethiopia?
Offer a terse response. 3.28. In the year 2004, what is the difference between the Exports(as % of merchandise exports) in Euro area and Exports(as % of merchandise exports) in Italy?
Offer a terse response. 0.93. In the year 2004, what is the difference between the Exports(as % of merchandise exports) of Barbados and Exports(as % of merchandise exports) of Ethiopia?
Make the answer very short. 8.82. In the year 2004, what is the difference between the Exports(as % of merchandise exports) in Barbados and Exports(as % of merchandise exports) in Italy?
Provide a short and direct response. 6.47. In the year 2004, what is the difference between the Exports(as % of merchandise exports) in Ethiopia and Exports(as % of merchandise exports) in Italy?
Keep it short and to the point. -2.35. In the year 2007, what is the difference between the Exports(as % of merchandise exports) in Euro area and Exports(as % of merchandise exports) in Barbados?
Your response must be concise. -18.67. In the year 2007, what is the difference between the Exports(as % of merchandise exports) in Euro area and Exports(as % of merchandise exports) in Ethiopia?
Provide a short and direct response. 4.32. In the year 2007, what is the difference between the Exports(as % of merchandise exports) of Euro area and Exports(as % of merchandise exports) of Italy?
Your response must be concise. 0.46. In the year 2007, what is the difference between the Exports(as % of merchandise exports) in Barbados and Exports(as % of merchandise exports) in Ethiopia?
Provide a short and direct response. 22.98. In the year 2007, what is the difference between the Exports(as % of merchandise exports) in Barbados and Exports(as % of merchandise exports) in Italy?
Make the answer very short. 19.13. In the year 2007, what is the difference between the Exports(as % of merchandise exports) of Ethiopia and Exports(as % of merchandise exports) of Italy?
Offer a very short reply. -3.85. In the year 2008, what is the difference between the Exports(as % of merchandise exports) in Euro area and Exports(as % of merchandise exports) in Barbados?
Your answer should be very brief. -3.07. In the year 2008, what is the difference between the Exports(as % of merchandise exports) of Euro area and Exports(as % of merchandise exports) of Ethiopia?
Your answer should be very brief. 5.44. In the year 2008, what is the difference between the Exports(as % of merchandise exports) of Euro area and Exports(as % of merchandise exports) of Italy?
Provide a short and direct response. 0.82. In the year 2008, what is the difference between the Exports(as % of merchandise exports) of Barbados and Exports(as % of merchandise exports) of Ethiopia?
Offer a very short reply. 8.5. In the year 2008, what is the difference between the Exports(as % of merchandise exports) of Barbados and Exports(as % of merchandise exports) of Italy?
Provide a succinct answer. 3.88. In the year 2008, what is the difference between the Exports(as % of merchandise exports) in Ethiopia and Exports(as % of merchandise exports) in Italy?
Your answer should be compact. -4.62. In the year 2009, what is the difference between the Exports(as % of merchandise exports) in Euro area and Exports(as % of merchandise exports) in Barbados?
Offer a terse response. -0.87. In the year 2009, what is the difference between the Exports(as % of merchandise exports) of Euro area and Exports(as % of merchandise exports) of Ethiopia?
Keep it short and to the point. 4.32. In the year 2009, what is the difference between the Exports(as % of merchandise exports) in Euro area and Exports(as % of merchandise exports) in Italy?
Your answer should be compact. 0.74. In the year 2009, what is the difference between the Exports(as % of merchandise exports) in Barbados and Exports(as % of merchandise exports) in Ethiopia?
Your response must be concise. 5.18. In the year 2009, what is the difference between the Exports(as % of merchandise exports) of Barbados and Exports(as % of merchandise exports) of Italy?
Your response must be concise. 1.61. In the year 2009, what is the difference between the Exports(as % of merchandise exports) of Ethiopia and Exports(as % of merchandise exports) of Italy?
Offer a very short reply. -3.57. In the year 2010, what is the difference between the Exports(as % of merchandise exports) of Euro area and Exports(as % of merchandise exports) of Barbados?
Give a very brief answer. 4.92. In the year 2010, what is the difference between the Exports(as % of merchandise exports) in Euro area and Exports(as % of merchandise exports) in Ethiopia?
Offer a terse response. 4.93. In the year 2010, what is the difference between the Exports(as % of merchandise exports) of Euro area and Exports(as % of merchandise exports) of Italy?
Provide a short and direct response. 0.25. In the year 2010, what is the difference between the Exports(as % of merchandise exports) in Barbados and Exports(as % of merchandise exports) in Ethiopia?
Give a very brief answer. 0.02. In the year 2010, what is the difference between the Exports(as % of merchandise exports) of Barbados and Exports(as % of merchandise exports) of Italy?
Provide a succinct answer. -4.66. In the year 2010, what is the difference between the Exports(as % of merchandise exports) in Ethiopia and Exports(as % of merchandise exports) in Italy?
Ensure brevity in your answer.  -4.68. In the year 2011, what is the difference between the Exports(as % of merchandise exports) in Euro area and Exports(as % of merchandise exports) in Barbados?
Make the answer very short. -1.27. In the year 2011, what is the difference between the Exports(as % of merchandise exports) in Euro area and Exports(as % of merchandise exports) in Ethiopia?
Ensure brevity in your answer.  6.11. In the year 2011, what is the difference between the Exports(as % of merchandise exports) in Euro area and Exports(as % of merchandise exports) in Italy?
Give a very brief answer. 1.32. In the year 2011, what is the difference between the Exports(as % of merchandise exports) of Barbados and Exports(as % of merchandise exports) of Ethiopia?
Your response must be concise. 7.38. In the year 2011, what is the difference between the Exports(as % of merchandise exports) in Barbados and Exports(as % of merchandise exports) in Italy?
Keep it short and to the point. 2.59. In the year 2011, what is the difference between the Exports(as % of merchandise exports) in Ethiopia and Exports(as % of merchandise exports) in Italy?
Make the answer very short. -4.79. In the year 2012, what is the difference between the Exports(as % of merchandise exports) of Euro area and Exports(as % of merchandise exports) of Barbados?
Offer a very short reply. -4.33. In the year 2012, what is the difference between the Exports(as % of merchandise exports) in Euro area and Exports(as % of merchandise exports) in Ethiopia?
Make the answer very short. 6.48. In the year 2012, what is the difference between the Exports(as % of merchandise exports) of Euro area and Exports(as % of merchandise exports) of Italy?
Keep it short and to the point. 1.76. In the year 2012, what is the difference between the Exports(as % of merchandise exports) of Barbados and Exports(as % of merchandise exports) of Ethiopia?
Provide a short and direct response. 10.81. In the year 2012, what is the difference between the Exports(as % of merchandise exports) of Barbados and Exports(as % of merchandise exports) of Italy?
Your answer should be compact. 6.09. In the year 2012, what is the difference between the Exports(as % of merchandise exports) in Ethiopia and Exports(as % of merchandise exports) in Italy?
Your answer should be very brief. -4.72. What is the ratio of the Exports(as % of merchandise exports) in Euro area in 2003 to that in 2004?
Provide a short and direct response. 0.9. What is the ratio of the Exports(as % of merchandise exports) of Barbados in 2003 to that in 2004?
Offer a very short reply. 0.85. What is the ratio of the Exports(as % of merchandise exports) in Ethiopia in 2003 to that in 2004?
Provide a short and direct response. 1.63. What is the ratio of the Exports(as % of merchandise exports) of Italy in 2003 to that in 2004?
Provide a succinct answer. 0.92. What is the ratio of the Exports(as % of merchandise exports) in Euro area in 2003 to that in 2007?
Ensure brevity in your answer.  0.68. What is the ratio of the Exports(as % of merchandise exports) of Barbados in 2003 to that in 2007?
Your answer should be very brief. 0.32. What is the ratio of the Exports(as % of merchandise exports) of Ethiopia in 2003 to that in 2007?
Make the answer very short. 1.23. What is the ratio of the Exports(as % of merchandise exports) of Italy in 2003 to that in 2007?
Your answer should be compact. 0.56. What is the ratio of the Exports(as % of merchandise exports) of Euro area in 2003 to that in 2008?
Keep it short and to the point. 0.54. What is the ratio of the Exports(as % of merchandise exports) in Barbados in 2003 to that in 2008?
Your response must be concise. 0.88. What is the ratio of the Exports(as % of merchandise exports) of Ethiopia in 2003 to that in 2008?
Your answer should be very brief. 1.48. What is the ratio of the Exports(as % of merchandise exports) of Italy in 2003 to that in 2008?
Keep it short and to the point. 0.47. What is the ratio of the Exports(as % of merchandise exports) in Euro area in 2003 to that in 2009?
Your response must be concise. 0.68. What is the ratio of the Exports(as % of merchandise exports) of Barbados in 2003 to that in 2009?
Give a very brief answer. 1.44. What is the ratio of the Exports(as % of merchandise exports) in Ethiopia in 2003 to that in 2009?
Your answer should be compact. 8.88. What is the ratio of the Exports(as % of merchandise exports) of Italy in 2003 to that in 2009?
Your answer should be compact. 0.6. What is the ratio of the Exports(as % of merchandise exports) in Euro area in 2003 to that in 2010?
Your response must be concise. 0.6. What is the ratio of the Exports(as % of merchandise exports) in Barbados in 2003 to that in 2010?
Ensure brevity in your answer.  345.12. What is the ratio of the Exports(as % of merchandise exports) in Ethiopia in 2003 to that in 2010?
Offer a terse response. 2. What is the ratio of the Exports(as % of merchandise exports) of Italy in 2003 to that in 2010?
Your response must be concise. 0.46. What is the ratio of the Exports(as % of merchandise exports) of Euro area in 2003 to that in 2011?
Provide a short and direct response. 0.48. What is the ratio of the Exports(as % of merchandise exports) of Barbados in 2003 to that in 2011?
Keep it short and to the point. 1.01. What is the ratio of the Exports(as % of merchandise exports) in Ethiopia in 2003 to that in 2011?
Make the answer very short. 753.21. What is the ratio of the Exports(as % of merchandise exports) in Italy in 2003 to that in 2011?
Offer a very short reply. 0.45. What is the ratio of the Exports(as % of merchandise exports) in Euro area in 2003 to that in 2012?
Provide a short and direct response. 0.45. What is the ratio of the Exports(as % of merchandise exports) in Barbados in 2003 to that in 2012?
Your response must be concise. 0.69. What is the ratio of the Exports(as % of merchandise exports) in Ethiopia in 2003 to that in 2012?
Your response must be concise. 3.95. What is the ratio of the Exports(as % of merchandise exports) in Italy in 2003 to that in 2012?
Ensure brevity in your answer.  0.46. What is the ratio of the Exports(as % of merchandise exports) of Euro area in 2004 to that in 2007?
Offer a terse response. 0.76. What is the ratio of the Exports(as % of merchandise exports) of Barbados in 2004 to that in 2007?
Your answer should be very brief. 0.38. What is the ratio of the Exports(as % of merchandise exports) in Ethiopia in 2004 to that in 2007?
Offer a very short reply. 0.76. What is the ratio of the Exports(as % of merchandise exports) in Italy in 2004 to that in 2007?
Your answer should be very brief. 0.61. What is the ratio of the Exports(as % of merchandise exports) of Euro area in 2004 to that in 2008?
Ensure brevity in your answer.  0.6. What is the ratio of the Exports(as % of merchandise exports) in Barbados in 2004 to that in 2008?
Provide a short and direct response. 1.04. What is the ratio of the Exports(as % of merchandise exports) in Ethiopia in 2004 to that in 2008?
Offer a very short reply. 0.91. What is the ratio of the Exports(as % of merchandise exports) in Italy in 2004 to that in 2008?
Ensure brevity in your answer.  0.51. What is the ratio of the Exports(as % of merchandise exports) in Euro area in 2004 to that in 2009?
Ensure brevity in your answer.  0.76. What is the ratio of the Exports(as % of merchandise exports) of Barbados in 2004 to that in 2009?
Provide a succinct answer. 1.7. What is the ratio of the Exports(as % of merchandise exports) of Ethiopia in 2004 to that in 2009?
Keep it short and to the point. 5.46. What is the ratio of the Exports(as % of merchandise exports) in Italy in 2004 to that in 2009?
Keep it short and to the point. 0.66. What is the ratio of the Exports(as % of merchandise exports) of Euro area in 2004 to that in 2010?
Your response must be concise. 0.66. What is the ratio of the Exports(as % of merchandise exports) of Barbados in 2004 to that in 2010?
Your response must be concise. 407.95. What is the ratio of the Exports(as % of merchandise exports) in Ethiopia in 2004 to that in 2010?
Give a very brief answer. 1.23. What is the ratio of the Exports(as % of merchandise exports) in Italy in 2004 to that in 2010?
Make the answer very short. 0.5. What is the ratio of the Exports(as % of merchandise exports) in Euro area in 2004 to that in 2011?
Offer a terse response. 0.54. What is the ratio of the Exports(as % of merchandise exports) in Barbados in 2004 to that in 2011?
Your answer should be very brief. 1.2. What is the ratio of the Exports(as % of merchandise exports) of Ethiopia in 2004 to that in 2011?
Make the answer very short. 463.48. What is the ratio of the Exports(as % of merchandise exports) in Italy in 2004 to that in 2011?
Offer a terse response. 0.49. What is the ratio of the Exports(as % of merchandise exports) of Euro area in 2004 to that in 2012?
Offer a terse response. 0.51. What is the ratio of the Exports(as % of merchandise exports) of Barbados in 2004 to that in 2012?
Keep it short and to the point. 0.82. What is the ratio of the Exports(as % of merchandise exports) of Ethiopia in 2004 to that in 2012?
Your answer should be very brief. 2.43. What is the ratio of the Exports(as % of merchandise exports) in Italy in 2004 to that in 2012?
Keep it short and to the point. 0.5. What is the ratio of the Exports(as % of merchandise exports) of Euro area in 2007 to that in 2008?
Your answer should be very brief. 0.79. What is the ratio of the Exports(as % of merchandise exports) of Barbados in 2007 to that in 2008?
Keep it short and to the point. 2.7. What is the ratio of the Exports(as % of merchandise exports) in Ethiopia in 2007 to that in 2008?
Offer a very short reply. 1.2. What is the ratio of the Exports(as % of merchandise exports) of Italy in 2007 to that in 2008?
Your answer should be compact. 0.83. What is the ratio of the Exports(as % of merchandise exports) in Euro area in 2007 to that in 2009?
Your response must be concise. 1. What is the ratio of the Exports(as % of merchandise exports) in Barbados in 2007 to that in 2009?
Keep it short and to the point. 4.43. What is the ratio of the Exports(as % of merchandise exports) of Ethiopia in 2007 to that in 2009?
Keep it short and to the point. 7.21. What is the ratio of the Exports(as % of merchandise exports) of Italy in 2007 to that in 2009?
Offer a very short reply. 1.08. What is the ratio of the Exports(as % of merchandise exports) of Euro area in 2007 to that in 2010?
Keep it short and to the point. 0.88. What is the ratio of the Exports(as % of merchandise exports) of Barbados in 2007 to that in 2010?
Provide a succinct answer. 1062.64. What is the ratio of the Exports(as % of merchandise exports) of Ethiopia in 2007 to that in 2010?
Offer a very short reply. 1.62. What is the ratio of the Exports(as % of merchandise exports) of Italy in 2007 to that in 2010?
Offer a terse response. 0.82. What is the ratio of the Exports(as % of merchandise exports) in Euro area in 2007 to that in 2011?
Provide a succinct answer. 0.71. What is the ratio of the Exports(as % of merchandise exports) of Barbados in 2007 to that in 2011?
Ensure brevity in your answer.  3.12. What is the ratio of the Exports(as % of merchandise exports) of Ethiopia in 2007 to that in 2011?
Keep it short and to the point. 611.64. What is the ratio of the Exports(as % of merchandise exports) in Italy in 2007 to that in 2011?
Your answer should be compact. 0.81. What is the ratio of the Exports(as % of merchandise exports) of Euro area in 2007 to that in 2012?
Your response must be concise. 0.67. What is the ratio of the Exports(as % of merchandise exports) in Barbados in 2007 to that in 2012?
Keep it short and to the point. 2.13. What is the ratio of the Exports(as % of merchandise exports) of Ethiopia in 2007 to that in 2012?
Keep it short and to the point. 3.21. What is the ratio of the Exports(as % of merchandise exports) in Italy in 2007 to that in 2012?
Your answer should be very brief. 0.82. What is the ratio of the Exports(as % of merchandise exports) in Euro area in 2008 to that in 2009?
Your answer should be compact. 1.26. What is the ratio of the Exports(as % of merchandise exports) in Barbados in 2008 to that in 2009?
Your answer should be compact. 1.64. What is the ratio of the Exports(as % of merchandise exports) of Ethiopia in 2008 to that in 2009?
Keep it short and to the point. 6. What is the ratio of the Exports(as % of merchandise exports) in Italy in 2008 to that in 2009?
Offer a terse response. 1.29. What is the ratio of the Exports(as % of merchandise exports) of Euro area in 2008 to that in 2010?
Your answer should be compact. 1.1. What is the ratio of the Exports(as % of merchandise exports) in Barbados in 2008 to that in 2010?
Provide a succinct answer. 393.37. What is the ratio of the Exports(as % of merchandise exports) of Ethiopia in 2008 to that in 2010?
Give a very brief answer. 1.35. What is the ratio of the Exports(as % of merchandise exports) of Italy in 2008 to that in 2010?
Your answer should be compact. 0.99. What is the ratio of the Exports(as % of merchandise exports) in Euro area in 2008 to that in 2011?
Offer a very short reply. 0.89. What is the ratio of the Exports(as % of merchandise exports) in Barbados in 2008 to that in 2011?
Offer a terse response. 1.15. What is the ratio of the Exports(as % of merchandise exports) in Ethiopia in 2008 to that in 2011?
Make the answer very short. 508.81. What is the ratio of the Exports(as % of merchandise exports) of Italy in 2008 to that in 2011?
Provide a short and direct response. 0.97. What is the ratio of the Exports(as % of merchandise exports) of Euro area in 2008 to that in 2012?
Make the answer very short. 0.84. What is the ratio of the Exports(as % of merchandise exports) of Barbados in 2008 to that in 2012?
Your response must be concise. 0.79. What is the ratio of the Exports(as % of merchandise exports) of Ethiopia in 2008 to that in 2012?
Give a very brief answer. 2.67. What is the ratio of the Exports(as % of merchandise exports) in Italy in 2008 to that in 2012?
Keep it short and to the point. 0.98. What is the ratio of the Exports(as % of merchandise exports) of Euro area in 2009 to that in 2010?
Ensure brevity in your answer.  0.87. What is the ratio of the Exports(as % of merchandise exports) in Barbados in 2009 to that in 2010?
Offer a very short reply. 239.66. What is the ratio of the Exports(as % of merchandise exports) of Ethiopia in 2009 to that in 2010?
Your answer should be compact. 0.23. What is the ratio of the Exports(as % of merchandise exports) in Italy in 2009 to that in 2010?
Your answer should be very brief. 0.76. What is the ratio of the Exports(as % of merchandise exports) in Euro area in 2009 to that in 2011?
Give a very brief answer. 0.71. What is the ratio of the Exports(as % of merchandise exports) of Barbados in 2009 to that in 2011?
Make the answer very short. 0.7. What is the ratio of the Exports(as % of merchandise exports) of Ethiopia in 2009 to that in 2011?
Provide a succinct answer. 84.82. What is the ratio of the Exports(as % of merchandise exports) of Italy in 2009 to that in 2011?
Offer a terse response. 0.75. What is the ratio of the Exports(as % of merchandise exports) of Euro area in 2009 to that in 2012?
Offer a very short reply. 0.67. What is the ratio of the Exports(as % of merchandise exports) of Barbados in 2009 to that in 2012?
Provide a short and direct response. 0.48. What is the ratio of the Exports(as % of merchandise exports) in Ethiopia in 2009 to that in 2012?
Keep it short and to the point. 0.45. What is the ratio of the Exports(as % of merchandise exports) in Italy in 2009 to that in 2012?
Give a very brief answer. 0.76. What is the ratio of the Exports(as % of merchandise exports) in Euro area in 2010 to that in 2011?
Your response must be concise. 0.81. What is the ratio of the Exports(as % of merchandise exports) in Barbados in 2010 to that in 2011?
Offer a very short reply. 0. What is the ratio of the Exports(as % of merchandise exports) in Ethiopia in 2010 to that in 2011?
Provide a succinct answer. 376.43. What is the ratio of the Exports(as % of merchandise exports) of Italy in 2010 to that in 2011?
Your response must be concise. 0.98. What is the ratio of the Exports(as % of merchandise exports) of Euro area in 2010 to that in 2012?
Provide a short and direct response. 0.76. What is the ratio of the Exports(as % of merchandise exports) in Barbados in 2010 to that in 2012?
Your answer should be compact. 0. What is the ratio of the Exports(as % of merchandise exports) of Ethiopia in 2010 to that in 2012?
Provide a short and direct response. 1.97. What is the ratio of the Exports(as % of merchandise exports) in Italy in 2010 to that in 2012?
Offer a terse response. 0.99. What is the ratio of the Exports(as % of merchandise exports) of Euro area in 2011 to that in 2012?
Your answer should be compact. 0.94. What is the ratio of the Exports(as % of merchandise exports) in Barbados in 2011 to that in 2012?
Offer a very short reply. 0.68. What is the ratio of the Exports(as % of merchandise exports) in Ethiopia in 2011 to that in 2012?
Your response must be concise. 0.01. What is the ratio of the Exports(as % of merchandise exports) of Italy in 2011 to that in 2012?
Your answer should be compact. 1.02. What is the difference between the highest and the second highest Exports(as % of merchandise exports) in Euro area?
Keep it short and to the point. 0.37. What is the difference between the highest and the second highest Exports(as % of merchandise exports) of Barbados?
Your answer should be very brief. 12.18. What is the difference between the highest and the second highest Exports(as % of merchandise exports) of Ethiopia?
Offer a very short reply. 0. What is the difference between the highest and the second highest Exports(as % of merchandise exports) of Italy?
Offer a very short reply. 0.07. What is the difference between the highest and the lowest Exports(as % of merchandise exports) in Euro area?
Your answer should be compact. 3.54. What is the difference between the highest and the lowest Exports(as % of merchandise exports) in Barbados?
Give a very brief answer. 22.97. What is the difference between the highest and the lowest Exports(as % of merchandise exports) of Ethiopia?
Your answer should be very brief. 0.01. What is the difference between the highest and the lowest Exports(as % of merchandise exports) in Italy?
Keep it short and to the point. 2.63. 